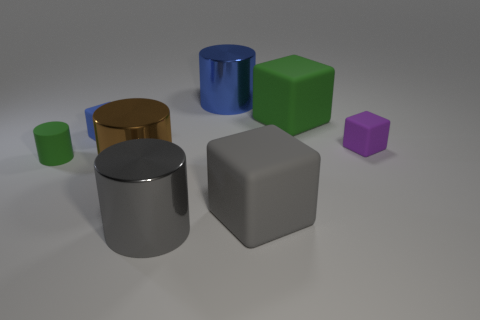What number of objects are small matte cubes left of the gray cube or purple matte things right of the big blue metal object?
Provide a succinct answer. 2. Is the number of brown metallic things that are on the left side of the big brown metal cylinder greater than the number of purple blocks that are to the left of the blue cylinder?
Offer a terse response. No. What color is the big shiny cylinder that is behind the small rubber cylinder?
Provide a succinct answer. Blue. Are there any other metal objects that have the same shape as the brown object?
Offer a terse response. Yes. How many gray things are either big blocks or blocks?
Give a very brief answer. 1. Are there any green objects of the same size as the blue cylinder?
Offer a terse response. Yes. What number of metal cylinders are there?
Your response must be concise. 3. What number of large things are red matte spheres or gray metallic things?
Keep it short and to the point. 1. There is a small cube that is on the left side of the gray thing right of the large thing that is in front of the large gray rubber object; what is its color?
Offer a very short reply. Blue. What number of other objects are the same color as the matte cylinder?
Keep it short and to the point. 1. 